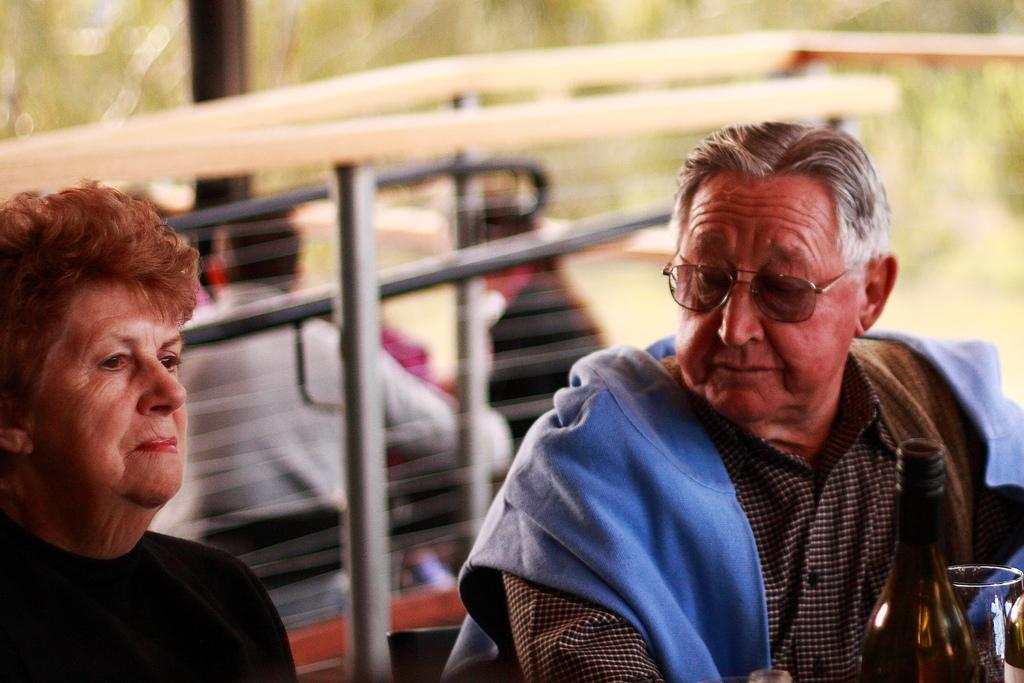How many people are in the center of the image? There are two persons in the center of the image. What objects can be seen besides the people in the image? There is a bottle and a glass in the image. Can you describe the background of the image? There are persons and rods in the background of the image. What type of fiction is being read by the person in the background? There is no person reading fiction in the background of the image; it only shows persons and rods. 